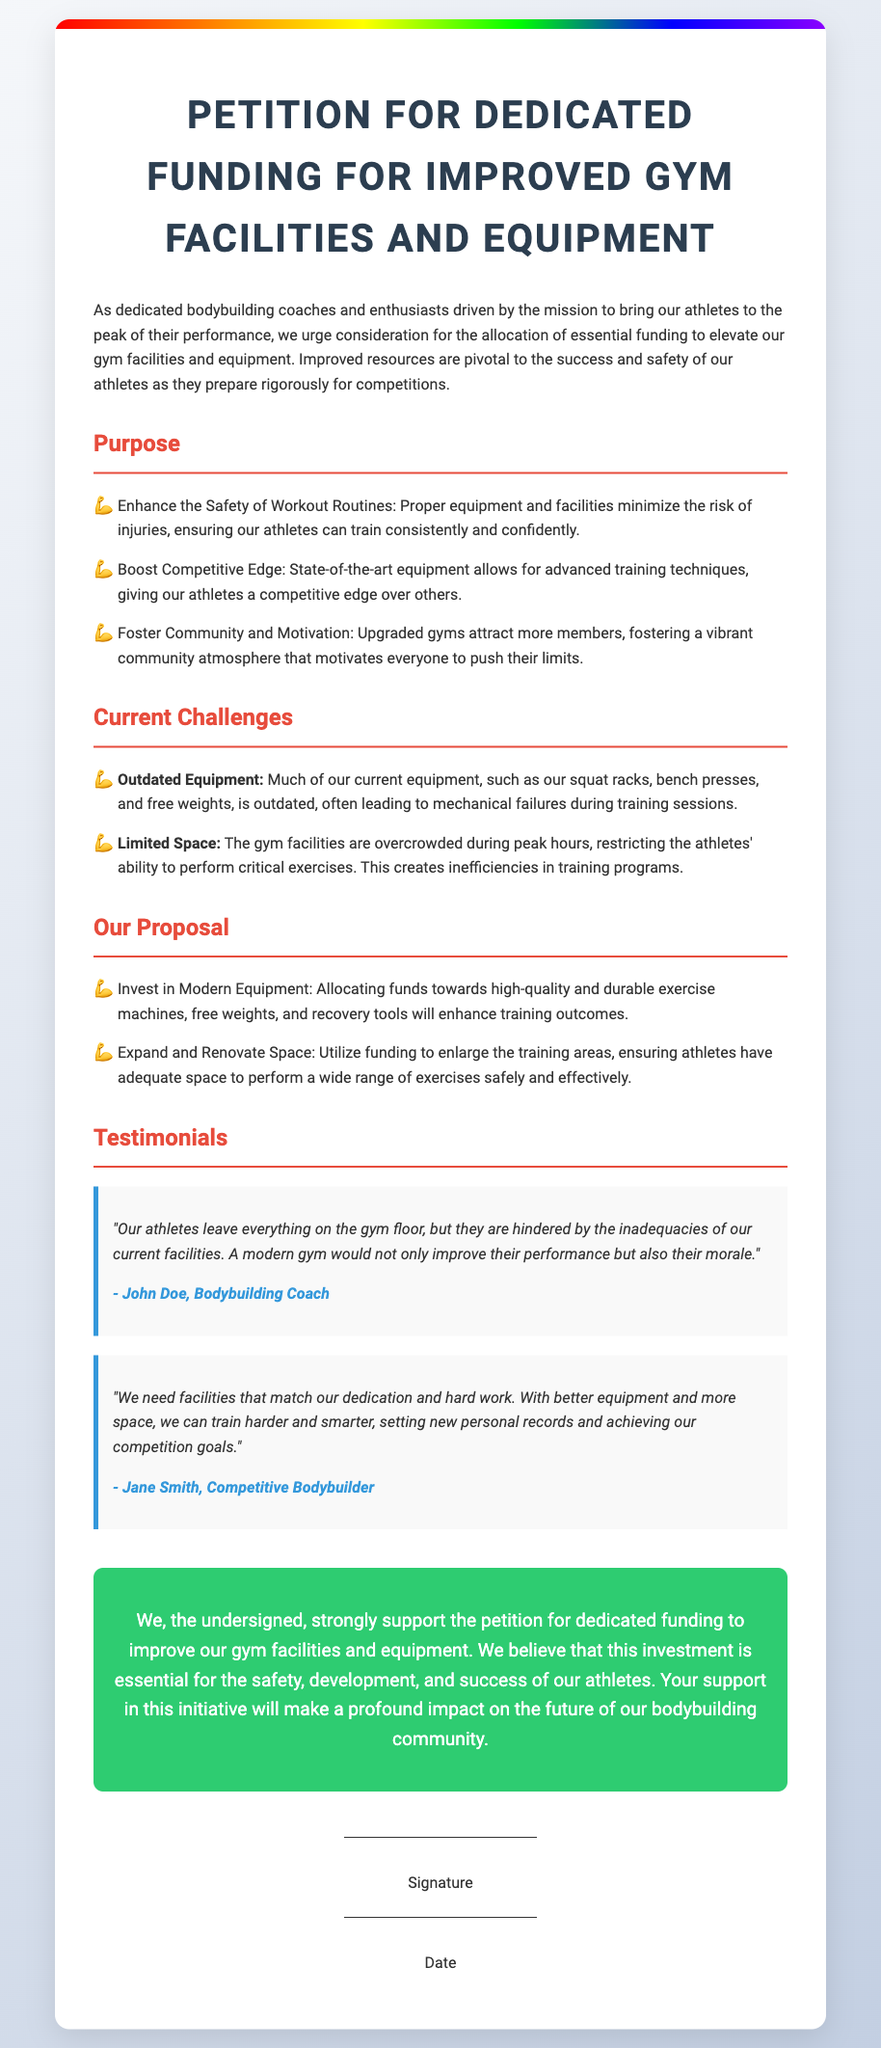What is the title of the petition? The title of the petition is displayed prominently at the top of the document.
Answer: Petition for Dedicated Funding for Improved Gym Facilities and Equipment What are the three purposes outlined in the petition? The purposes are explicitly listed under their own section, detailing the goals of the petition.
Answer: Enhance Safety, Boost Competitive Edge, Foster Community Who is the author of the first testimonial? The author of the testimonial is mentioned at the end of the quote.
Answer: John Doe What is a current challenge mentioned regarding gym facilities? The challenges are listed in a dedicated section, highlighting key issues with the current setup.
Answer: Outdated Equipment What is one of the proposals to improve gym facilities? Proposals are provided with clear bullet points indicating suggested improvements for the gym.
Answer: Invest in Modern Equipment How many testimonials are provided in the petition? The number of testimonials can be counted in the section where they are presented.
Answer: Two What color is the call-to-action (CTA) section? The color of the CTA section is described within the styling and can be visually identified.
Answer: Green What type of document is this? The signature area and its format indicate the nature of this document is primarily focused on gathering support.
Answer: Petition 